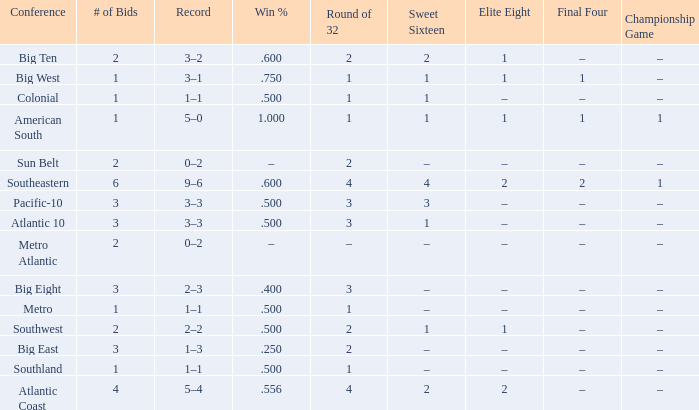What Sweet Sixteen team is in the Colonial conference? 1.0. 